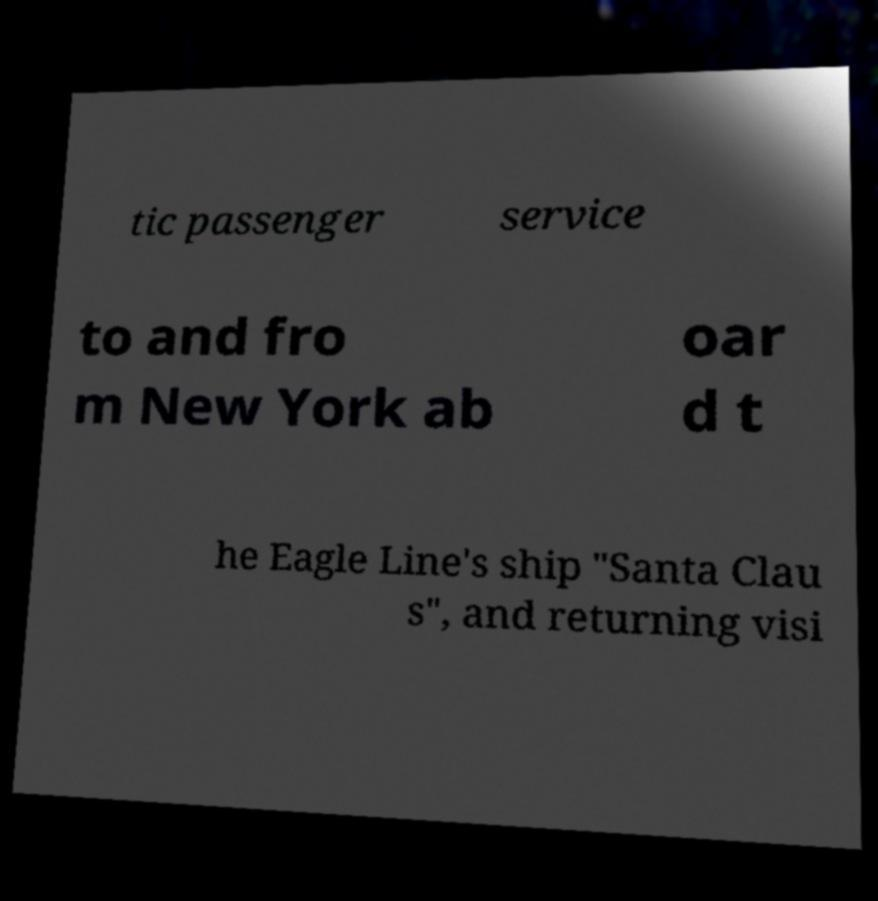What messages or text are displayed in this image? I need them in a readable, typed format. tic passenger service to and fro m New York ab oar d t he Eagle Line's ship "Santa Clau s", and returning visi 